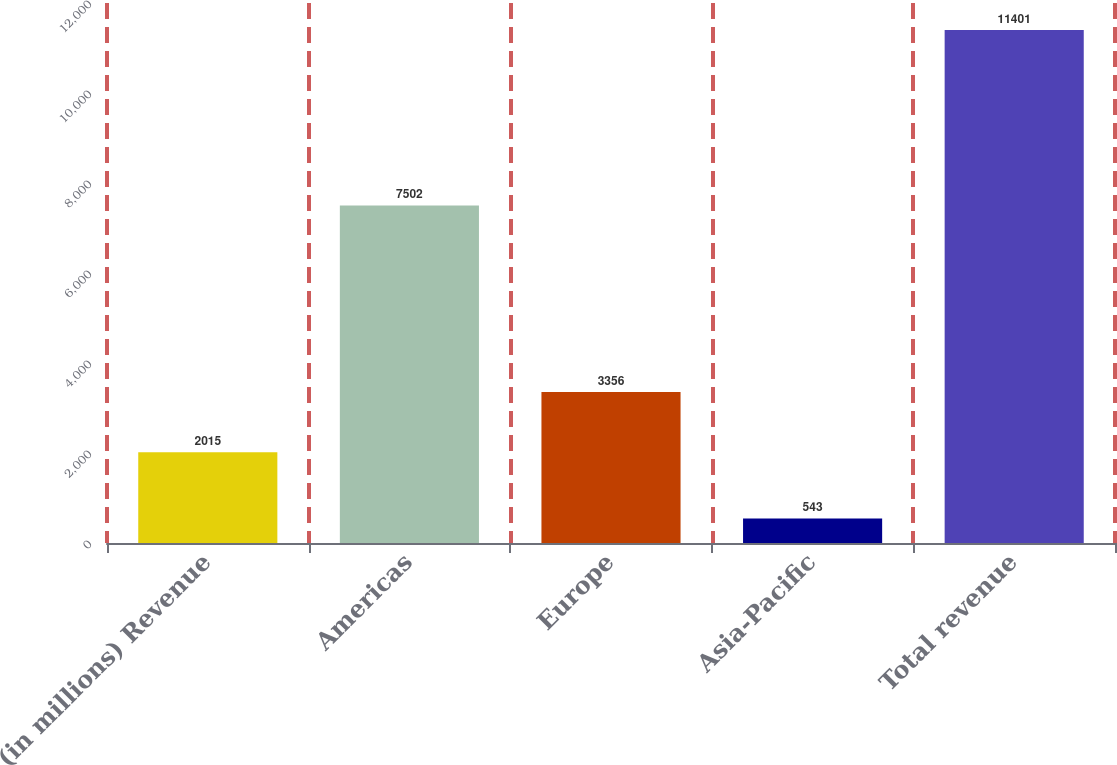<chart> <loc_0><loc_0><loc_500><loc_500><bar_chart><fcel>(in millions) Revenue<fcel>Americas<fcel>Europe<fcel>Asia-Pacific<fcel>Total revenue<nl><fcel>2015<fcel>7502<fcel>3356<fcel>543<fcel>11401<nl></chart> 